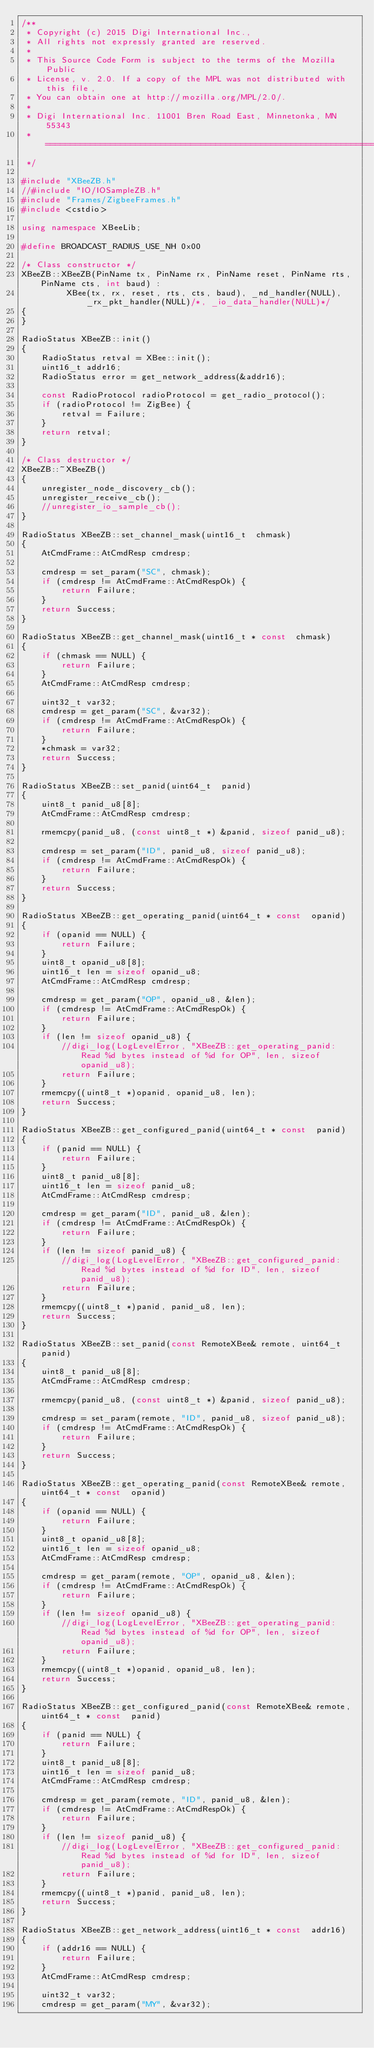Convert code to text. <code><loc_0><loc_0><loc_500><loc_500><_C++_>/**
 * Copyright (c) 2015 Digi International Inc.,
 * All rights not expressly granted are reserved.
 *
 * This Source Code Form is subject to the terms of the Mozilla Public
 * License, v. 2.0. If a copy of the MPL was not distributed with this file,
 * You can obtain one at http://mozilla.org/MPL/2.0/.
 *
 * Digi International Inc. 11001 Bren Road East, Minnetonka, MN 55343
 * =======================================================================
 */

#include "XBeeZB.h"
//#include "IO/IOSampleZB.h"
#include "Frames/ZigbeeFrames.h"
#include <cstdio>

using namespace XBeeLib;

#define BROADCAST_RADIUS_USE_NH 0x00

/* Class constructor */
XBeeZB::XBeeZB(PinName tx, PinName rx, PinName reset, PinName rts, PinName cts, int baud) :
         XBee(tx, rx, reset, rts, cts, baud), _nd_handler(NULL), _rx_pkt_handler(NULL)/*, _io_data_handler(NULL)*/
{
}

RadioStatus XBeeZB::init()
{
    RadioStatus retval = XBee::init();
    uint16_t addr16;
    RadioStatus error = get_network_address(&addr16);

    const RadioProtocol radioProtocol = get_radio_protocol();
    if (radioProtocol != ZigBee) {
        retval = Failure;
    }
    return retval;
}

/* Class destructor */
XBeeZB::~XBeeZB()
{
    unregister_node_discovery_cb();
    unregister_receive_cb();
    //unregister_io_sample_cb();
}

RadioStatus XBeeZB::set_channel_mask(uint16_t  chmask)
{
    AtCmdFrame::AtCmdResp cmdresp;

    cmdresp = set_param("SC", chmask);
    if (cmdresp != AtCmdFrame::AtCmdRespOk) {
        return Failure;
    }
    return Success;
}

RadioStatus XBeeZB::get_channel_mask(uint16_t * const  chmask)
{
    if (chmask == NULL) {
        return Failure;
    }
    AtCmdFrame::AtCmdResp cmdresp;

    uint32_t var32;
    cmdresp = get_param("SC", &var32);
    if (cmdresp != AtCmdFrame::AtCmdRespOk) {
        return Failure;
    }
    *chmask = var32;
    return Success;
}

RadioStatus XBeeZB::set_panid(uint64_t  panid)
{
    uint8_t panid_u8[8];
    AtCmdFrame::AtCmdResp cmdresp;

    rmemcpy(panid_u8, (const uint8_t *) &panid, sizeof panid_u8);

    cmdresp = set_param("ID", panid_u8, sizeof panid_u8);
    if (cmdresp != AtCmdFrame::AtCmdRespOk) {
        return Failure;
    }
    return Success;
}

RadioStatus XBeeZB::get_operating_panid(uint64_t * const  opanid)
{
    if (opanid == NULL) {
        return Failure;
    }
    uint8_t opanid_u8[8];
    uint16_t len = sizeof opanid_u8;
    AtCmdFrame::AtCmdResp cmdresp;

    cmdresp = get_param("OP", opanid_u8, &len);
    if (cmdresp != AtCmdFrame::AtCmdRespOk) {
        return Failure;
    }
    if (len != sizeof opanid_u8) {
        //digi_log(LogLevelError, "XBeeZB::get_operating_panid: Read %d bytes instead of %d for OP", len, sizeof opanid_u8);
        return Failure;
    }
    rmemcpy((uint8_t *)opanid, opanid_u8, len);
    return Success;
}

RadioStatus XBeeZB::get_configured_panid(uint64_t * const  panid)
{
    if (panid == NULL) {
        return Failure;
    }
    uint8_t panid_u8[8];
    uint16_t len = sizeof panid_u8;
    AtCmdFrame::AtCmdResp cmdresp;

    cmdresp = get_param("ID", panid_u8, &len);
    if (cmdresp != AtCmdFrame::AtCmdRespOk) {
        return Failure;
    }
    if (len != sizeof panid_u8) {
        //digi_log(LogLevelError, "XBeeZB::get_configured_panid: Read %d bytes instead of %d for ID", len, sizeof panid_u8);
        return Failure;
    }
    rmemcpy((uint8_t *)panid, panid_u8, len);
    return Success;
}

RadioStatus XBeeZB::set_panid(const RemoteXBee& remote, uint64_t  panid)
{
    uint8_t panid_u8[8];
    AtCmdFrame::AtCmdResp cmdresp;

    rmemcpy(panid_u8, (const uint8_t *) &panid, sizeof panid_u8);

    cmdresp = set_param(remote, "ID", panid_u8, sizeof panid_u8);
    if (cmdresp != AtCmdFrame::AtCmdRespOk) {
        return Failure;
    }
    return Success;
}

RadioStatus XBeeZB::get_operating_panid(const RemoteXBee& remote, uint64_t * const  opanid)
{
    if (opanid == NULL) {
        return Failure;
    }
    uint8_t opanid_u8[8];
    uint16_t len = sizeof opanid_u8;
    AtCmdFrame::AtCmdResp cmdresp;

    cmdresp = get_param(remote, "OP", opanid_u8, &len);
    if (cmdresp != AtCmdFrame::AtCmdRespOk) {
        return Failure;
    }
    if (len != sizeof opanid_u8) {
        //digi_log(LogLevelError, "XBeeZB::get_operating_panid: Read %d bytes instead of %d for OP", len, sizeof opanid_u8);
        return Failure;
    }
    rmemcpy((uint8_t *)opanid, opanid_u8, len);
    return Success;
}

RadioStatus XBeeZB::get_configured_panid(const RemoteXBee& remote, uint64_t * const  panid)
{
    if (panid == NULL) {
        return Failure;
    }
    uint8_t panid_u8[8];
    uint16_t len = sizeof panid_u8;
    AtCmdFrame::AtCmdResp cmdresp;

    cmdresp = get_param(remote, "ID", panid_u8, &len);
    if (cmdresp != AtCmdFrame::AtCmdRespOk) {
        return Failure;
    }
    if (len != sizeof panid_u8) {
        //digi_log(LogLevelError, "XBeeZB::get_configured_panid: Read %d bytes instead of %d for ID", len, sizeof panid_u8);
        return Failure;
    }
    rmemcpy((uint8_t *)panid, panid_u8, len);
    return Success;
}

RadioStatus XBeeZB::get_network_address(uint16_t * const  addr16)
{
    if (addr16 == NULL) {
        return Failure;
    }
    AtCmdFrame::AtCmdResp cmdresp;

    uint32_t var32;
    cmdresp = get_param("MY", &var32);</code> 